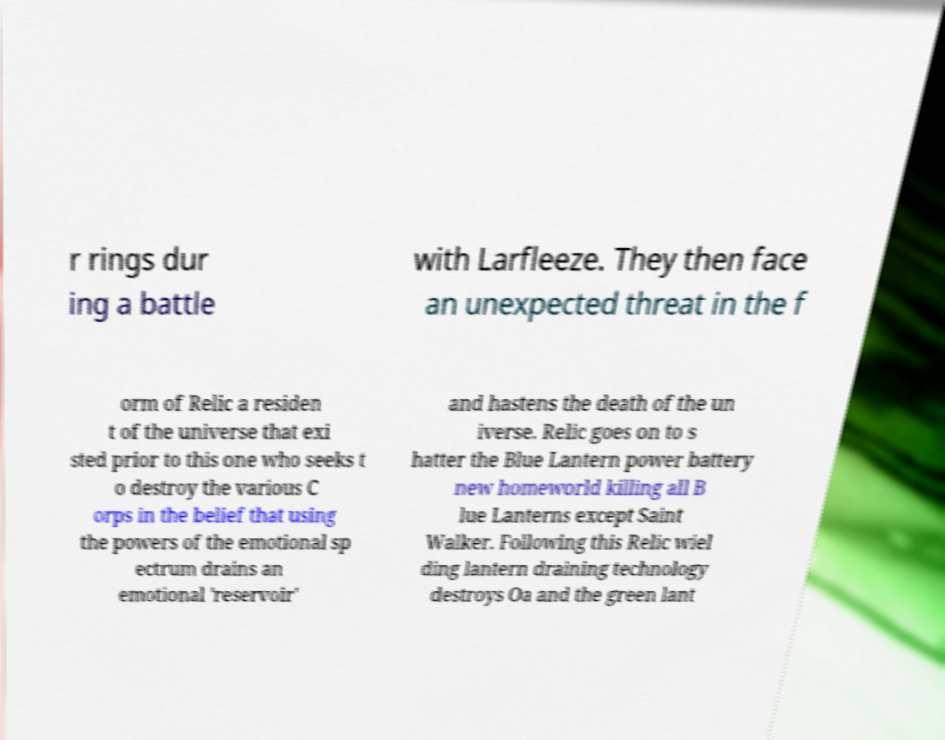For documentation purposes, I need the text within this image transcribed. Could you provide that? r rings dur ing a battle with Larfleeze. They then face an unexpected threat in the f orm of Relic a residen t of the universe that exi sted prior to this one who seeks t o destroy the various C orps in the belief that using the powers of the emotional sp ectrum drains an emotional 'reservoir' and hastens the death of the un iverse. Relic goes on to s hatter the Blue Lantern power battery new homeworld killing all B lue Lanterns except Saint Walker. Following this Relic wiel ding lantern draining technology destroys Oa and the green lant 